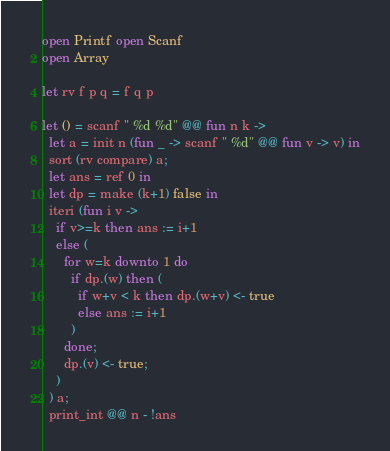<code> <loc_0><loc_0><loc_500><loc_500><_OCaml_>open Printf open Scanf
open Array

let rv f p q = f q p

let () = scanf " %d %d" @@ fun n k ->
  let a = init n (fun _ -> scanf " %d" @@ fun v -> v) in
  sort (rv compare) a;
  let ans = ref 0 in
  let dp = make (k+1) false in
  iteri (fun i v ->
    if v>=k then ans := i+1
    else (
      for w=k downto 1 do
        if dp.(w) then (
          if w+v < k then dp.(w+v) <- true
          else ans := i+1
        )
      done;
      dp.(v) <- true;
    )
  ) a;
  print_int @@ n - !ans



</code> 